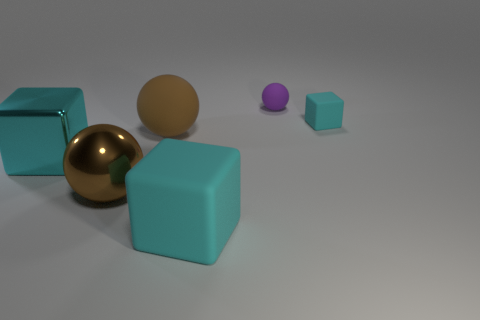Are there any cyan metallic cubes behind the brown rubber sphere?
Provide a short and direct response. No. How many big brown rubber objects have the same shape as the small purple rubber thing?
Give a very brief answer. 1. There is a rubber object that is behind the cyan block that is right of the block that is in front of the big metallic sphere; what color is it?
Give a very brief answer. Purple. Is the tiny thing that is behind the tiny cube made of the same material as the big brown sphere behind the cyan shiny object?
Ensure brevity in your answer.  Yes. What number of objects are either cyan things on the left side of the purple rubber sphere or tiny cyan rubber blocks?
Your response must be concise. 3. How many things are big cyan rubber blocks or matte balls that are on the left side of the purple matte object?
Ensure brevity in your answer.  2. What number of brown shiny objects have the same size as the metallic sphere?
Offer a very short reply. 0. Are there fewer objects that are on the right side of the small matte cube than tiny purple balls on the left side of the small purple rubber thing?
Keep it short and to the point. No. What number of shiny objects are tiny cyan things or cyan objects?
Ensure brevity in your answer.  1. The purple object is what shape?
Your answer should be very brief. Sphere. 